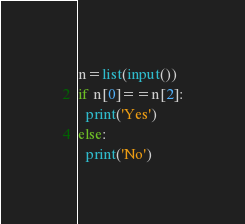Convert code to text. <code><loc_0><loc_0><loc_500><loc_500><_Python_>n=list(input())
if n[0]==n[2]:
  print('Yes')
else:
  print('No')</code> 